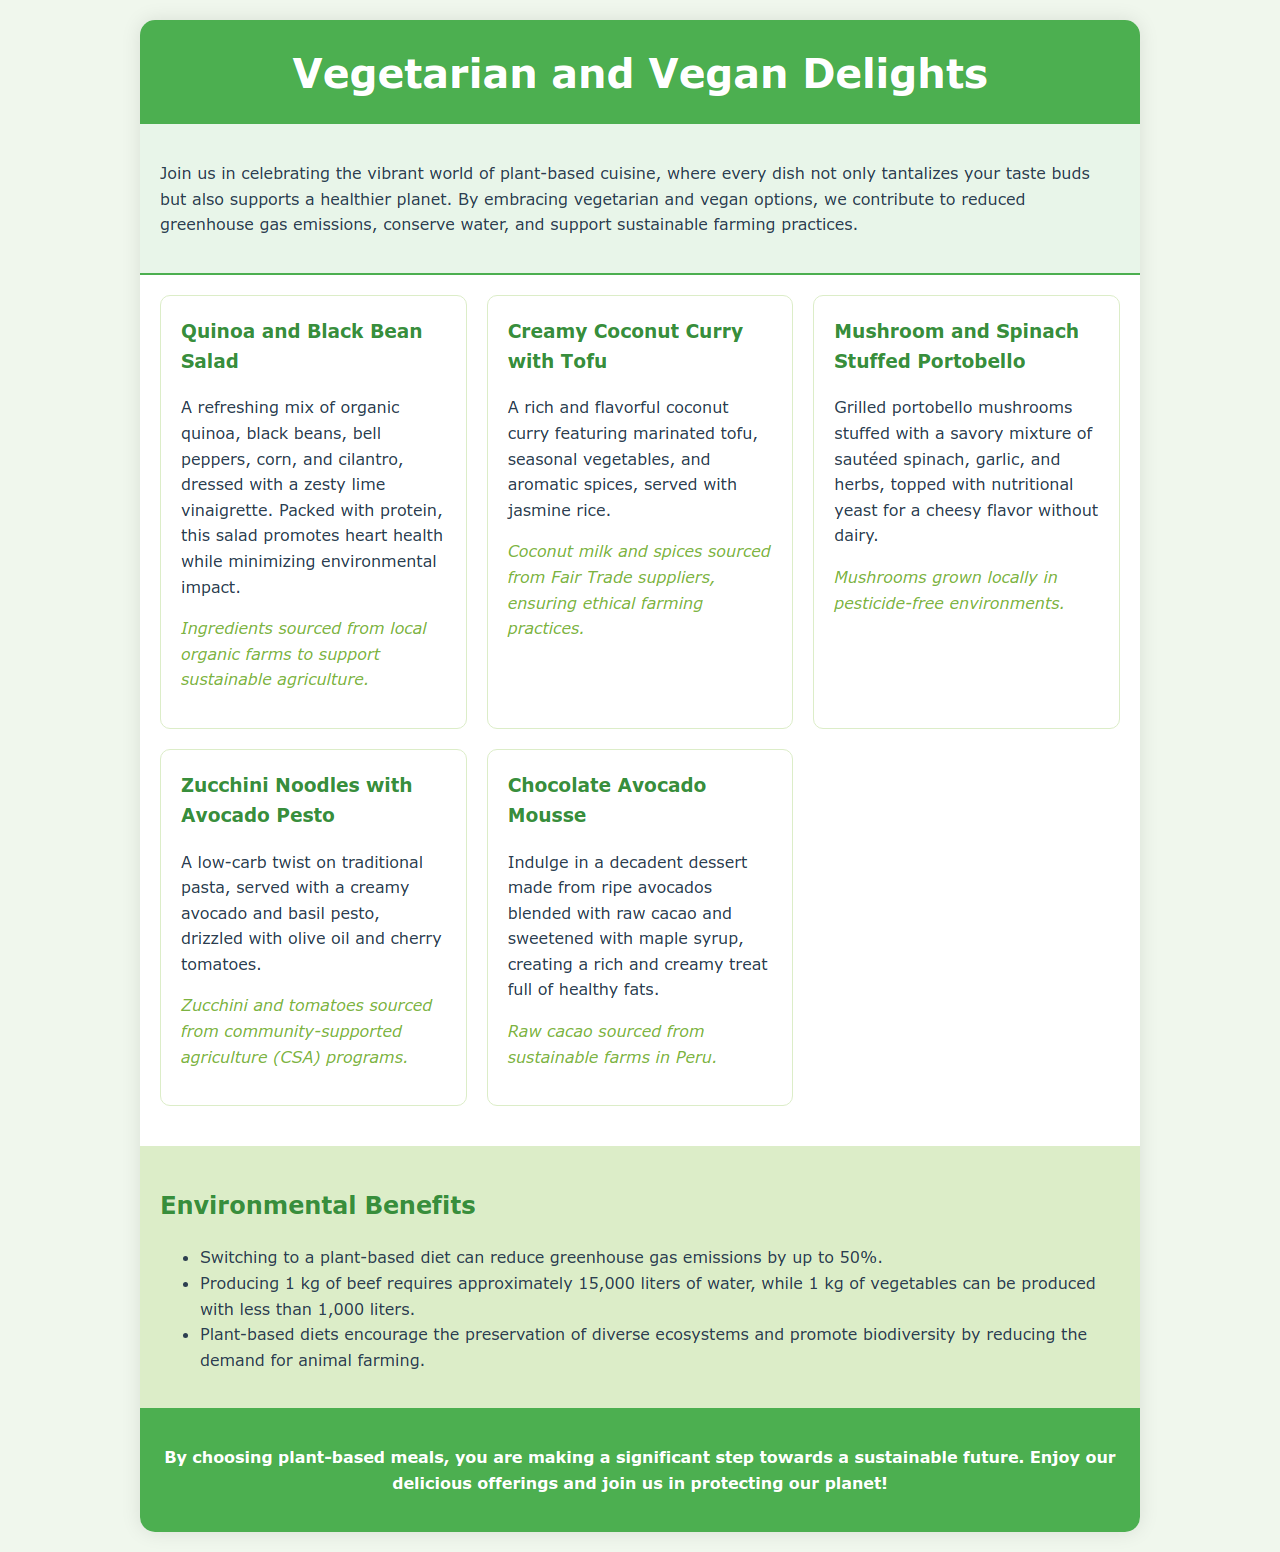what is the title of the menu? The title is presented prominently at the top of the document.
Answer: Vegetarian and Vegan Delights how many dishes are included in the menu? The menu section lists five distinct dishes.
Answer: 5 what is one ingredient in the Quinoa and Black Bean Salad? This dish includes organic quinoa, among other ingredients.
Answer: organic quinoa which dish features marinated tofu? The description of this dish mentions marinated tofu as a key component.
Answer: Creamy Coconut Curry with Tofu what is a benefit of switching to a plant-based diet? The document lists multiple environmental benefits, including reductions in greenhouse gas emissions.
Answer: reduce greenhouse gas emissions by up to 50% what type of farming is supported for the ingredients in the Mushroom and Spinach Stuffed Portobello? The sourcing section emphasizes the cultivation of these mushrooms in pesticide-free environments.
Answer: pesticide-free environments which dish is described as low-carb? The document specifically categorizes this dish based on its carbohydrate content.
Answer: Zucchini Noodles with Avocado Pesto what is one sourcing detail for the Chocolate Avocado Mousse? The sourcing section provides details about where the raw cacao is obtained.
Answer: sustainable farms in Peru 